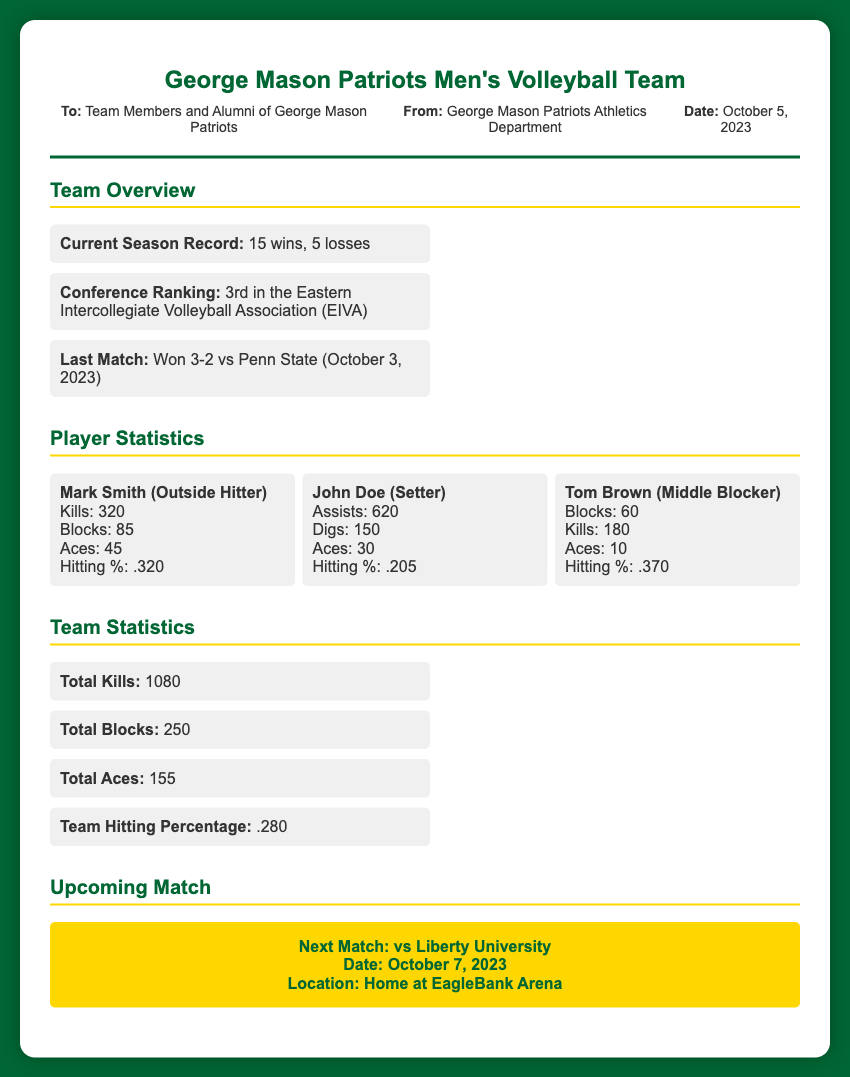what is the current season record? The current season record is presented under the team overview section, stating their wins and losses.
Answer: 15 wins, 5 losses what is the team's conference ranking? The conference ranking is included in the team overview section, indicating their status in the conference.
Answer: 3rd in the Eastern Intercollegiate Volleyball Association who is the player with the highest hitting percentage? The hitting percentages for each player can be found in their individual statistics, allowing for comparison.
Answer: Tom Brown how many assists has John Doe made? The specific number of assists is listed in John Doe's player statistics within the document.
Answer: 620 what was the result of the last match? The last match result is detailed in the team overview section, reflecting their recent performance.
Answer: Won 3-2 vs Penn State how many total blocks did the team achieve? Total blocks are provided in the team statistics section, summarizing the team's overall performance metrics.
Answer: 250 who is the next opponent of the team? The upcoming match section notes the next opponent, clarifying who they will compete against next.
Answer: Liberty University when is the next match scheduled? The date of the upcoming match is specifically mentioned in the upcoming match section of the memo.
Answer: October 7, 2023 what is the team hitting percentage? The team hitting percentage is part of the summarised team statistics in the document.
Answer: .280 